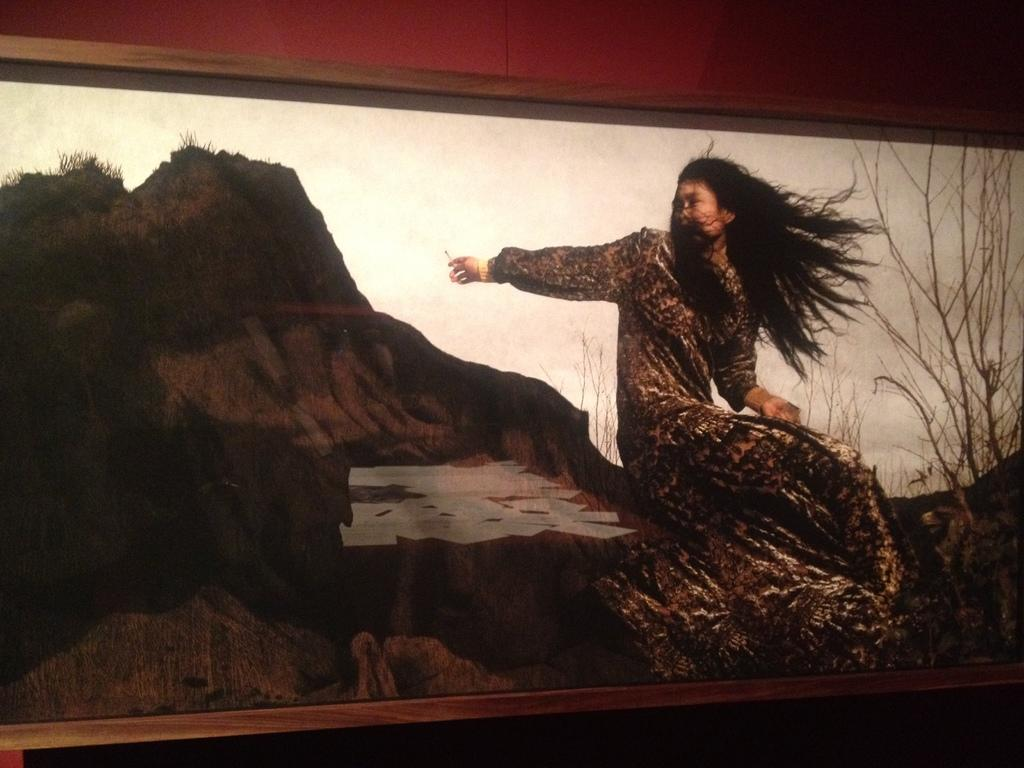What object is present in the image that typically holds a photograph? There is a photo frame in the image. What can be seen within the photo frame? The photo frame contains an image of a woman. What type of background is visible in the image within the photo frame? There are trees visible in the image within the photo frame. Can you tell me how many people are walking along the river in the image? There is no river or people walking in the image; it only contains a photo frame with an image of a woman and trees in the background. 